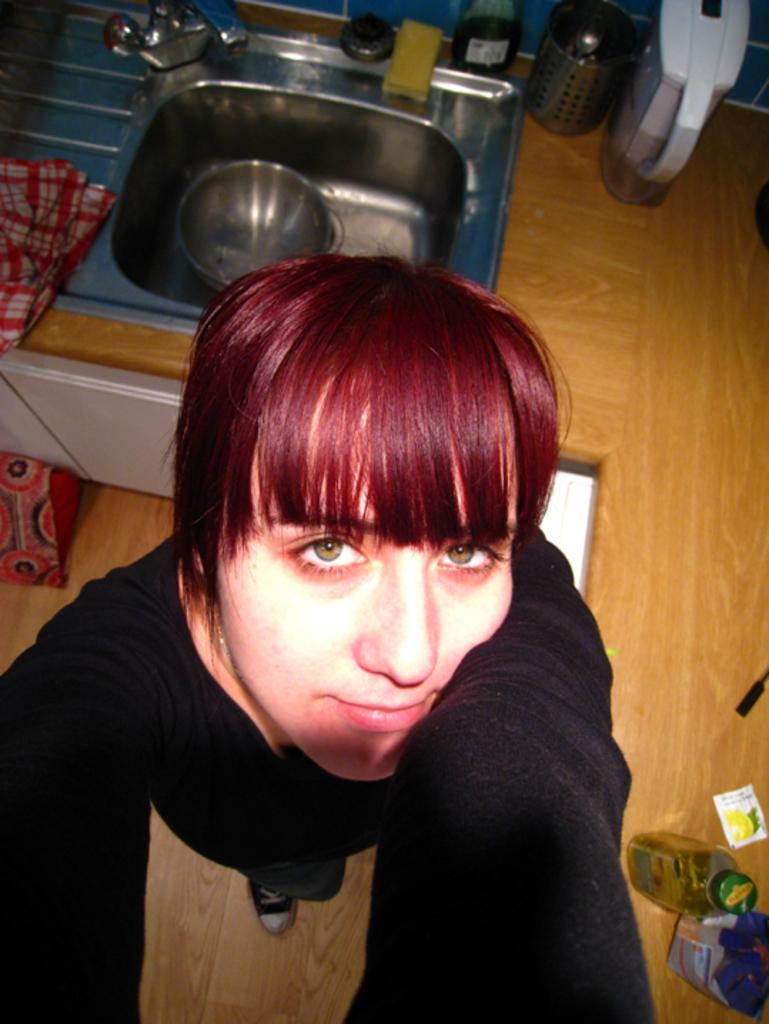Who is the main subject in the image? There is a woman in the image. What is the woman wearing? The woman is wearing a black t-shirt. Where is the woman positioned in the image? The woman is standing in the front of the image. What can be seen near the woman in the image? There is a wash basin and utensils beside the wash basin in the image. What type of chicken is being prepared in the image? There is no chicken present in the image; it features a woman standing in front of a wash basin with utensils beside it. How does the woman plan to use her credit card in the image? There is no credit card or any financial transaction depicted in the image. 